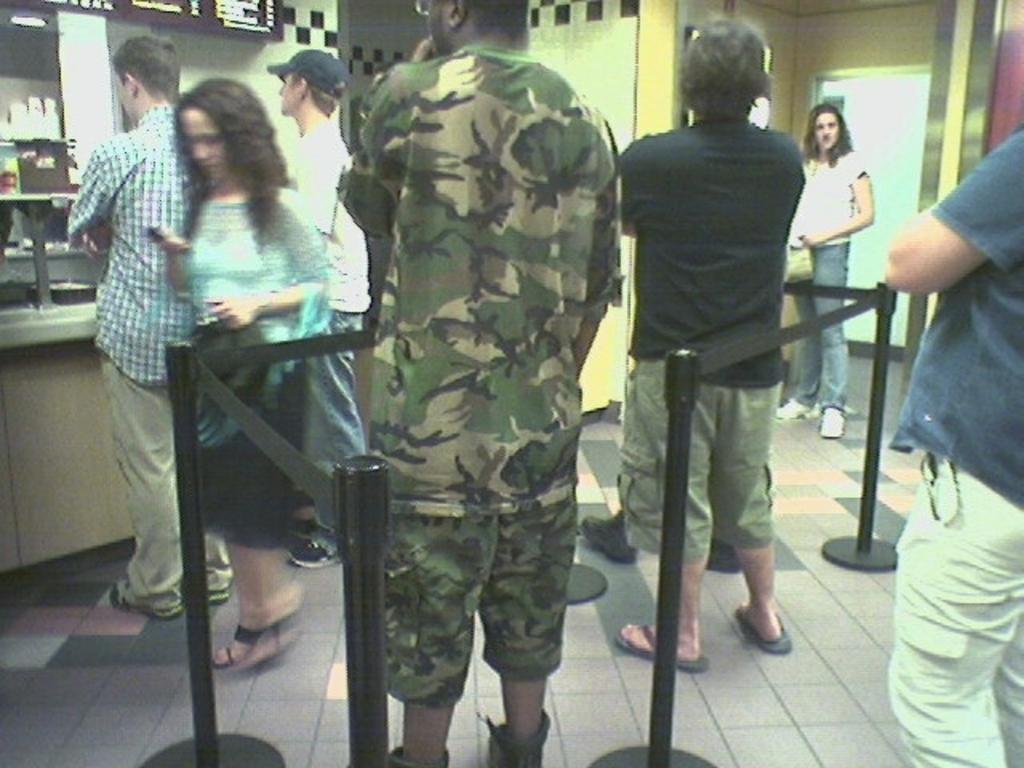Describe this image in one or two sentences. In the foreground of this image, there are persons standing on the floor and there are safety poles around them. In the background, there are few persons standing, a wall, few object in the shelf and a screen like an object on the top. 